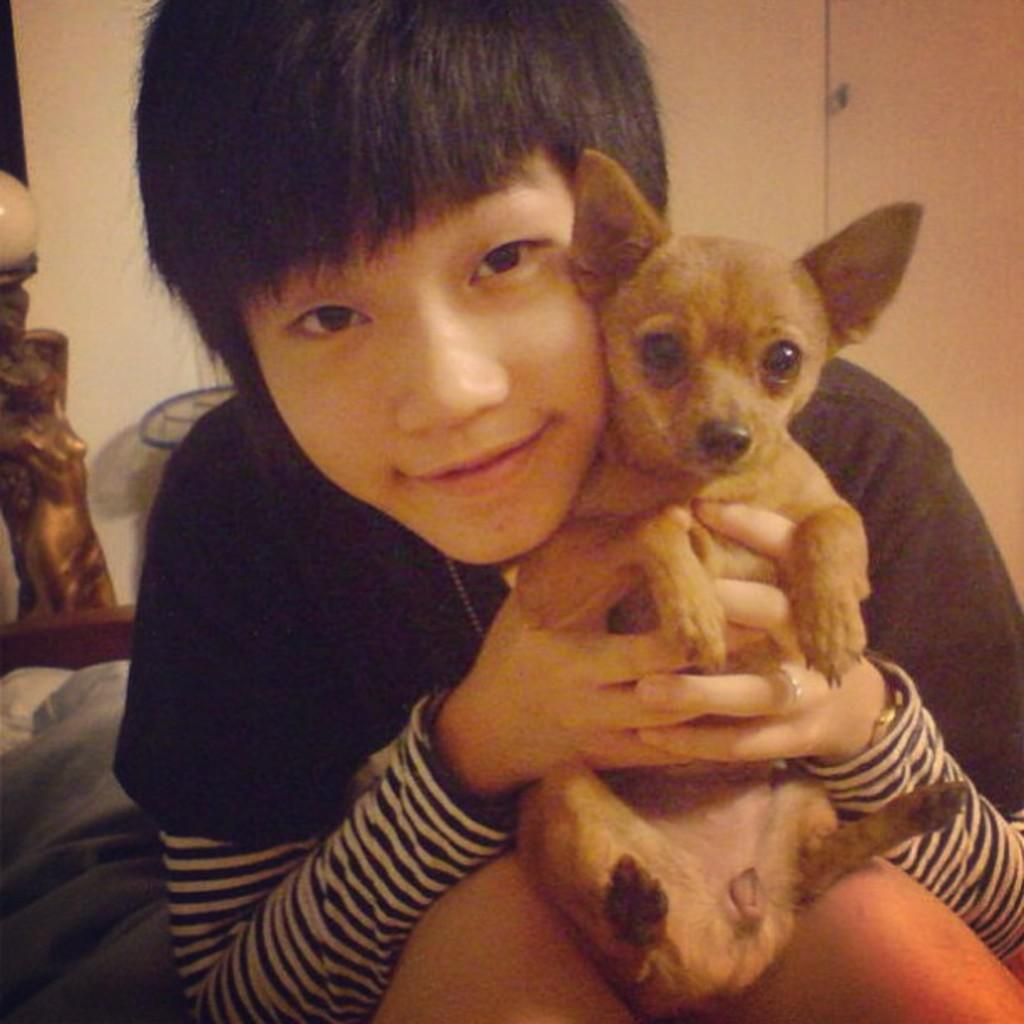What is the main subject of the image? The main subject of the image is a boy. What is the boy holding in the image? The boy is holding a puppy. How is the puppy being held by the boy? The puppy is in both hands of the boy. What type of cub can be seen in the image? There is no cub present in the image. What kind of shock is the boy experiencing in the image? There is no indication in the image that the boy is experiencing any shock. 